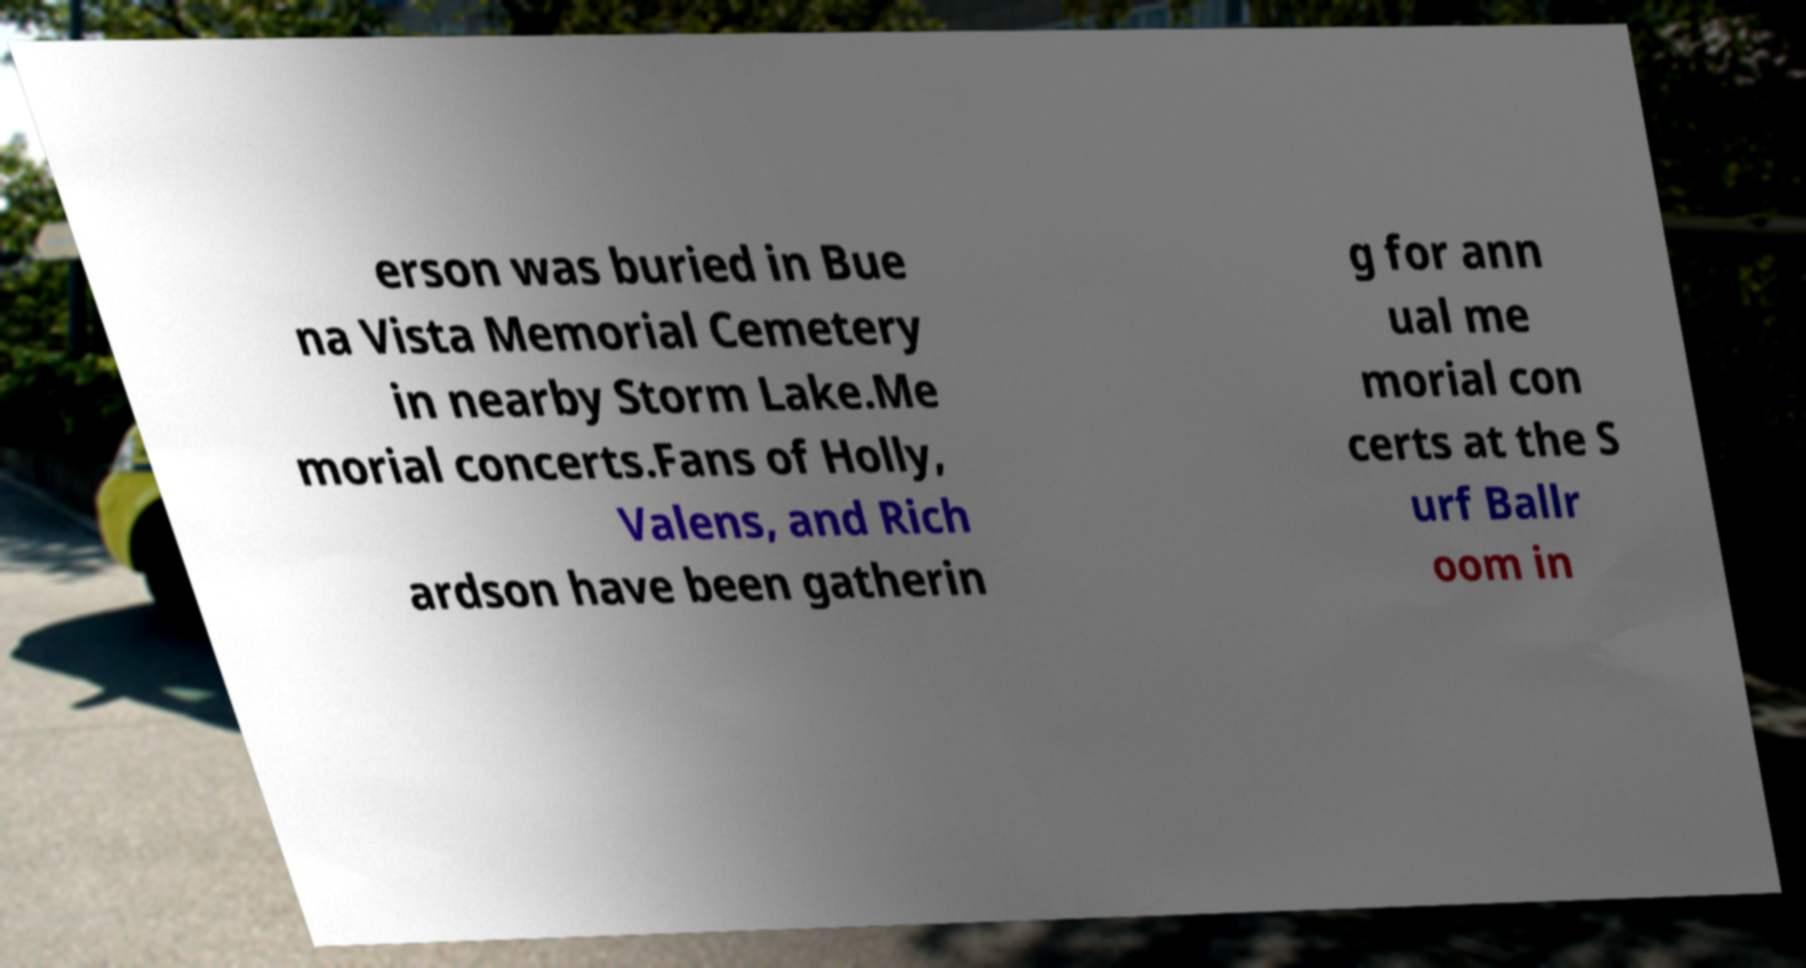Please identify and transcribe the text found in this image. erson was buried in Bue na Vista Memorial Cemetery in nearby Storm Lake.Me morial concerts.Fans of Holly, Valens, and Rich ardson have been gatherin g for ann ual me morial con certs at the S urf Ballr oom in 